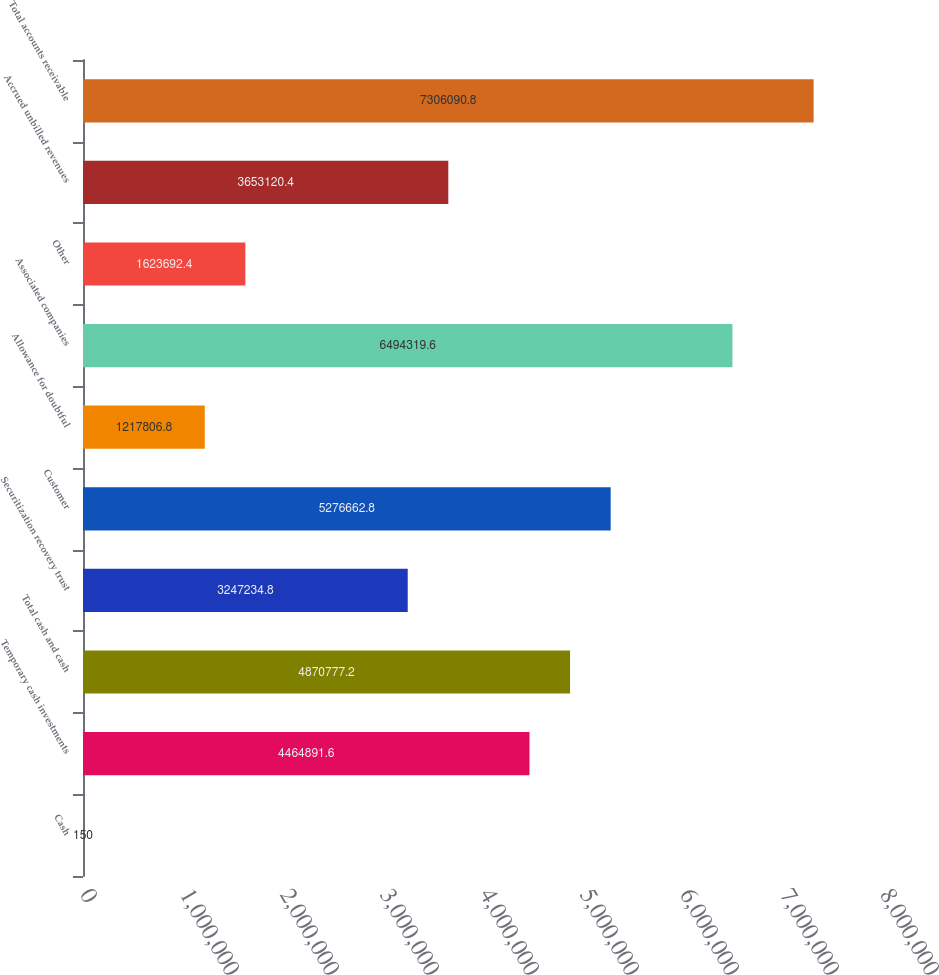<chart> <loc_0><loc_0><loc_500><loc_500><bar_chart><fcel>Cash<fcel>Temporary cash investments<fcel>Total cash and cash<fcel>Securitization recovery trust<fcel>Customer<fcel>Allowance for doubtful<fcel>Associated companies<fcel>Other<fcel>Accrued unbilled revenues<fcel>Total accounts receivable<nl><fcel>150<fcel>4.46489e+06<fcel>4.87078e+06<fcel>3.24723e+06<fcel>5.27666e+06<fcel>1.21781e+06<fcel>6.49432e+06<fcel>1.62369e+06<fcel>3.65312e+06<fcel>7.30609e+06<nl></chart> 